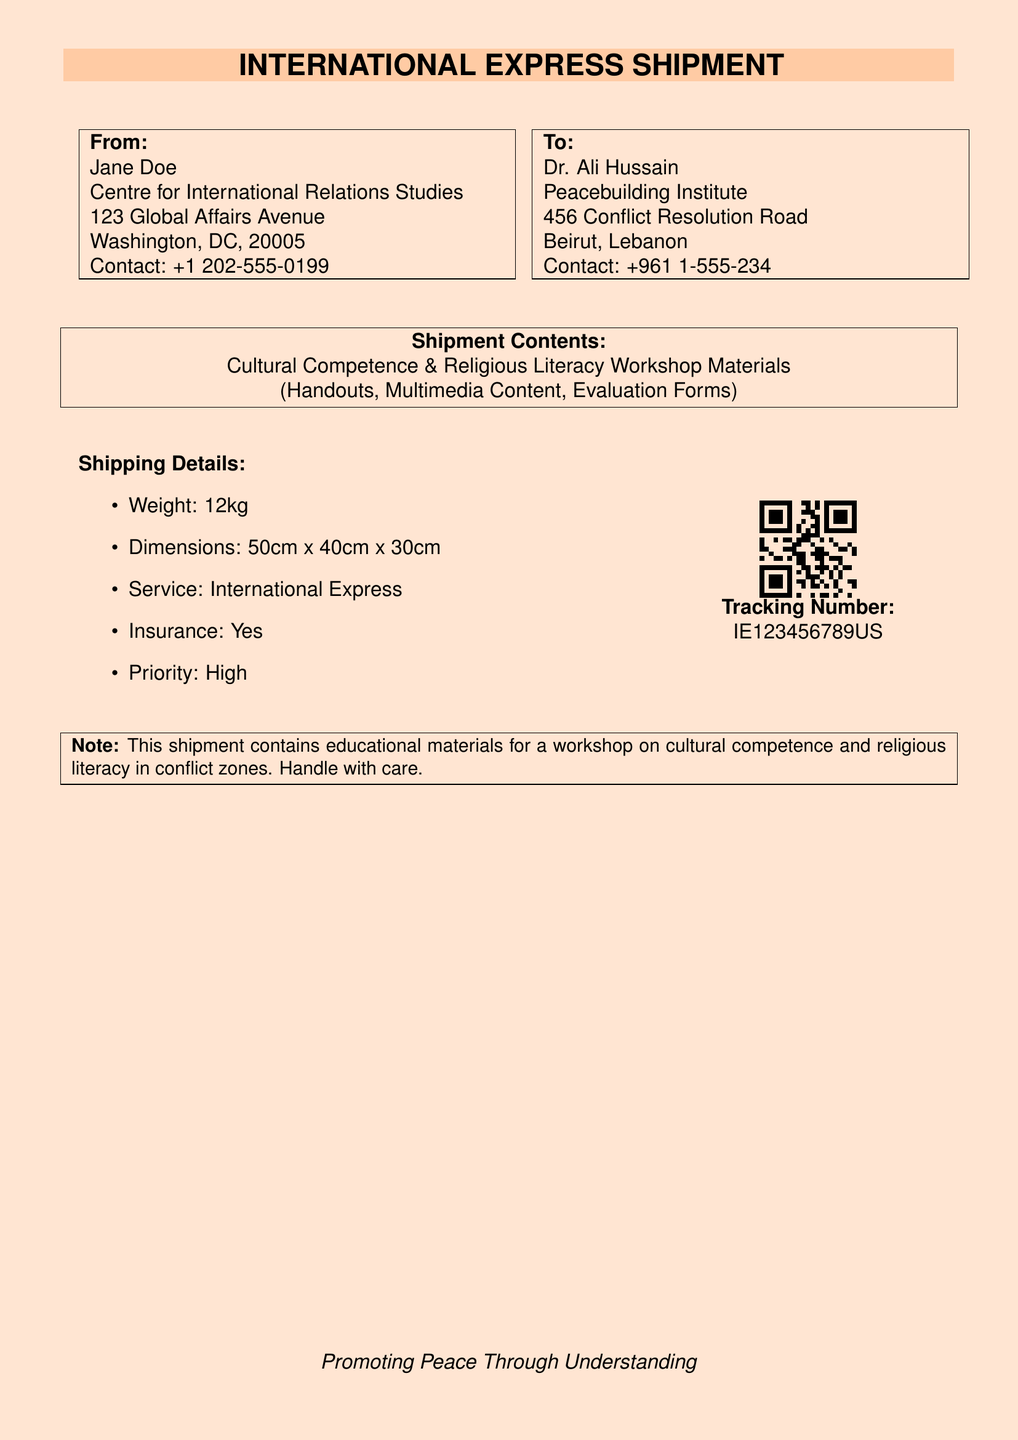What is the sender's name? The sender's name is provided at the top of the document, which is Jane Doe.
Answer: Jane Doe What is the weight of the shipment? The weight of the shipment is stated under the shipping details section, which mentions 12kg.
Answer: 12kg Where is the recipient located? The recipient's address is given in the 'To' section, specifically in Beirut, Lebanon.
Answer: Beirut, Lebanon What type of service is being used for shipment? The type of service for the shipment is specified in the shipping details, denoted as International Express.
Answer: International Express What items are included in the shipment? The contents of the shipment are listed, which includes Cultural Competence & Religious Literacy Workshop Materials.
Answer: Cultural Competence & Religious Literacy Workshop Materials What is the contact number for Jane Doe? The document provides the contact information for Jane Doe, which includes a specific phone number.
Answer: +1 202-555-0199 What is the tracking number for this shipment? The tracking number is highlighted in the QR code area, which can be found under the shipment details.
Answer: IE123456789US What should be noted about the shipment's contents? The document contains a note regarding the handling of the shipment, indicating to handle it with care.
Answer: Handle with care Why is the shipment described as priority? The priority of the shipment is classified in the shipping details and is referred to as 'High'.
Answer: High 